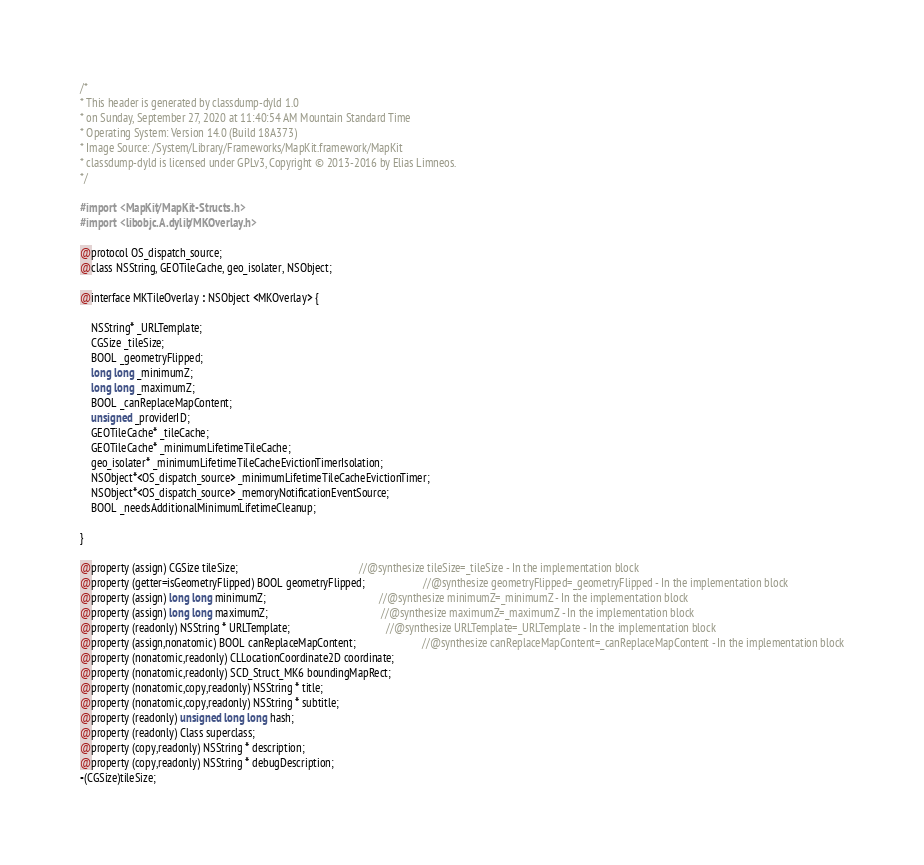<code> <loc_0><loc_0><loc_500><loc_500><_C_>/*
* This header is generated by classdump-dyld 1.0
* on Sunday, September 27, 2020 at 11:40:54 AM Mountain Standard Time
* Operating System: Version 14.0 (Build 18A373)
* Image Source: /System/Library/Frameworks/MapKit.framework/MapKit
* classdump-dyld is licensed under GPLv3, Copyright © 2013-2016 by Elias Limneos.
*/

#import <MapKit/MapKit-Structs.h>
#import <libobjc.A.dylib/MKOverlay.h>

@protocol OS_dispatch_source;
@class NSString, GEOTileCache, geo_isolater, NSObject;

@interface MKTileOverlay : NSObject <MKOverlay> {

	NSString* _URLTemplate;
	CGSize _tileSize;
	BOOL _geometryFlipped;
	long long _minimumZ;
	long long _maximumZ;
	BOOL _canReplaceMapContent;
	unsigned _providerID;
	GEOTileCache* _tileCache;
	GEOTileCache* _minimumLifetimeTileCache;
	geo_isolater* _minimumLifetimeTileCacheEvictionTimerIsolation;
	NSObject*<OS_dispatch_source> _minimumLifetimeTileCacheEvictionTimer;
	NSObject*<OS_dispatch_source> _memoryNotificationEventSource;
	BOOL _needsAdditionalMinimumLifetimeCleanup;

}

@property (assign) CGSize tileSize;                                            //@synthesize tileSize=_tileSize - In the implementation block
@property (getter=isGeometryFlipped) BOOL geometryFlipped;                     //@synthesize geometryFlipped=_geometryFlipped - In the implementation block
@property (assign) long long minimumZ;                                         //@synthesize minimumZ=_minimumZ - In the implementation block
@property (assign) long long maximumZ;                                         //@synthesize maximumZ=_maximumZ - In the implementation block
@property (readonly) NSString * URLTemplate;                                   //@synthesize URLTemplate=_URLTemplate - In the implementation block
@property (assign,nonatomic) BOOL canReplaceMapContent;                        //@synthesize canReplaceMapContent=_canReplaceMapContent - In the implementation block
@property (nonatomic,readonly) CLLocationCoordinate2D coordinate; 
@property (nonatomic,readonly) SCD_Struct_MK6 boundingMapRect; 
@property (nonatomic,copy,readonly) NSString * title; 
@property (nonatomic,copy,readonly) NSString * subtitle; 
@property (readonly) unsigned long long hash; 
@property (readonly) Class superclass; 
@property (copy,readonly) NSString * description; 
@property (copy,readonly) NSString * debugDescription; 
-(CGSize)tileSize;</code> 